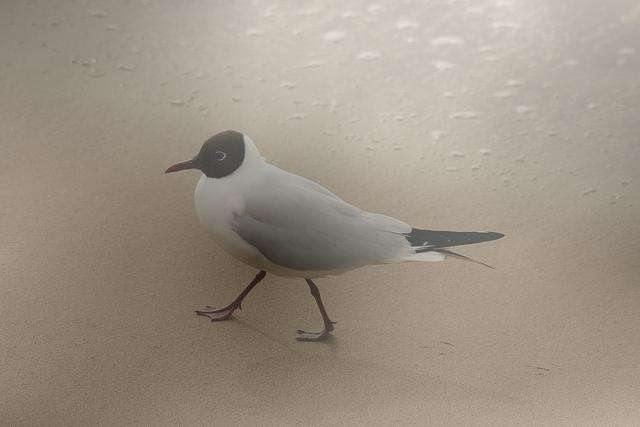How do the elements in this photo interact to create a composition? The composition is quite harmonious, with the lone seagull evenly positioned in the frame, denoting a focal point. The simplicity of the scene, with minimal elements, puts emphasis on the bird and its environment. The sand's texture and the gentle gradient of light to shadow lead the eye across the image and back to the bird, establishing a connection between the subject and its surroundings. 